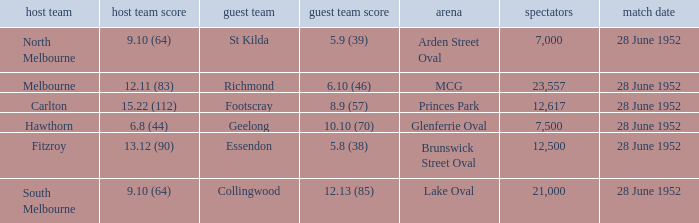What is the away team when north melbourne is at home? St Kilda. 